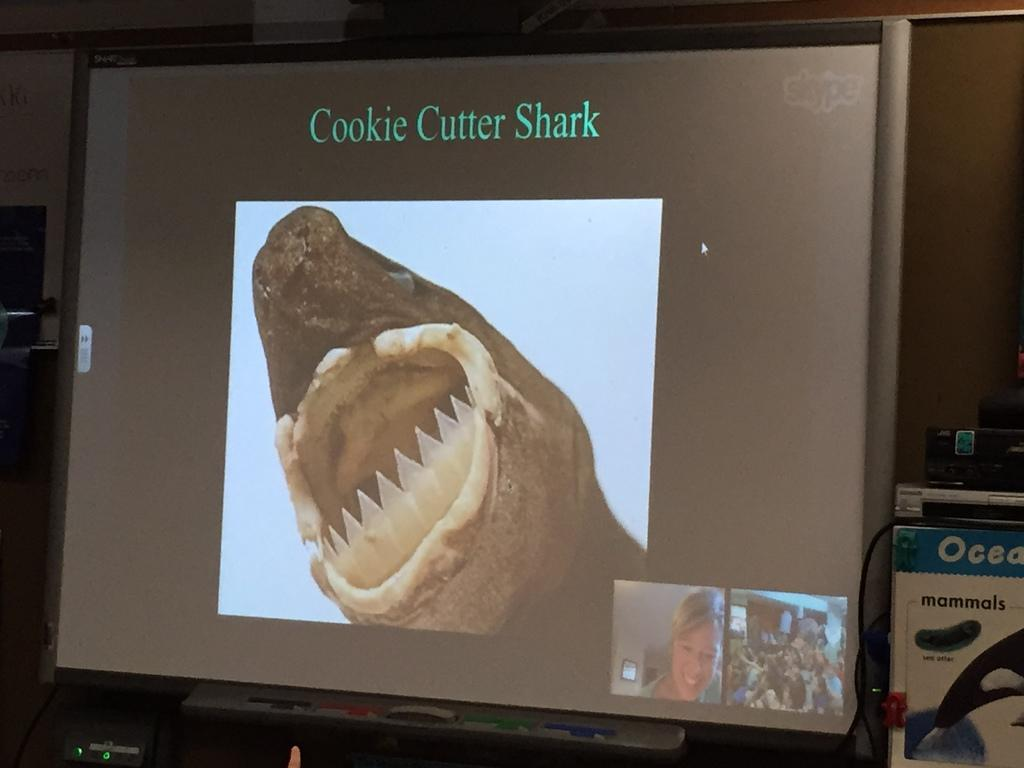<image>
Provide a brief description of the given image. A computer monitor shows and image of a sharks mouth with plastic teeth beneath the words Cookie Cutter Shark 